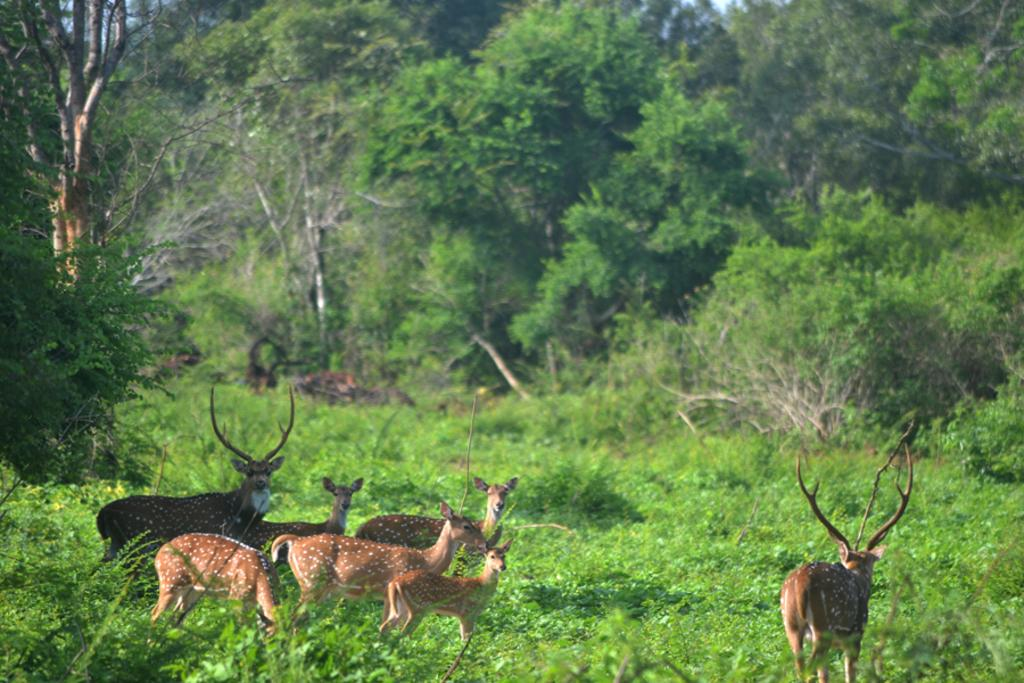What types of living organisms can be seen in the image? There are animals in the image. What can be seen in the background of the image? There are trees in the background of the image. What type of tin can be seen in the image? There is no tin present in the image. What color is the cat in the image? There is no cat present in the image. 